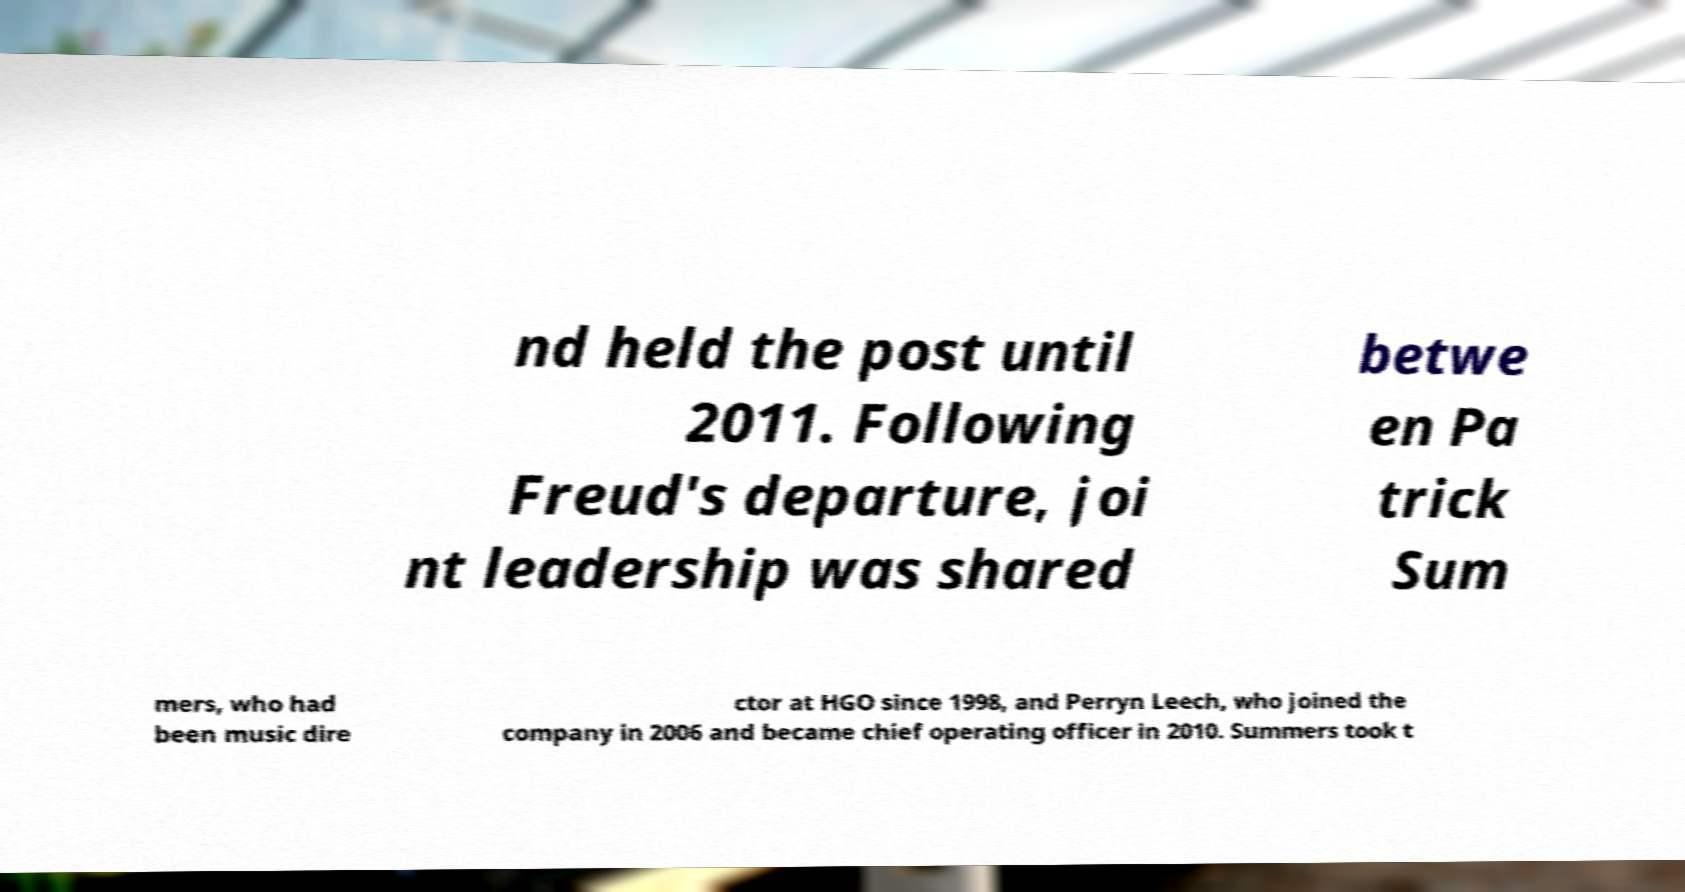There's text embedded in this image that I need extracted. Can you transcribe it verbatim? nd held the post until 2011. Following Freud's departure, joi nt leadership was shared betwe en Pa trick Sum mers, who had been music dire ctor at HGO since 1998, and Perryn Leech, who joined the company in 2006 and became chief operating officer in 2010. Summers took t 